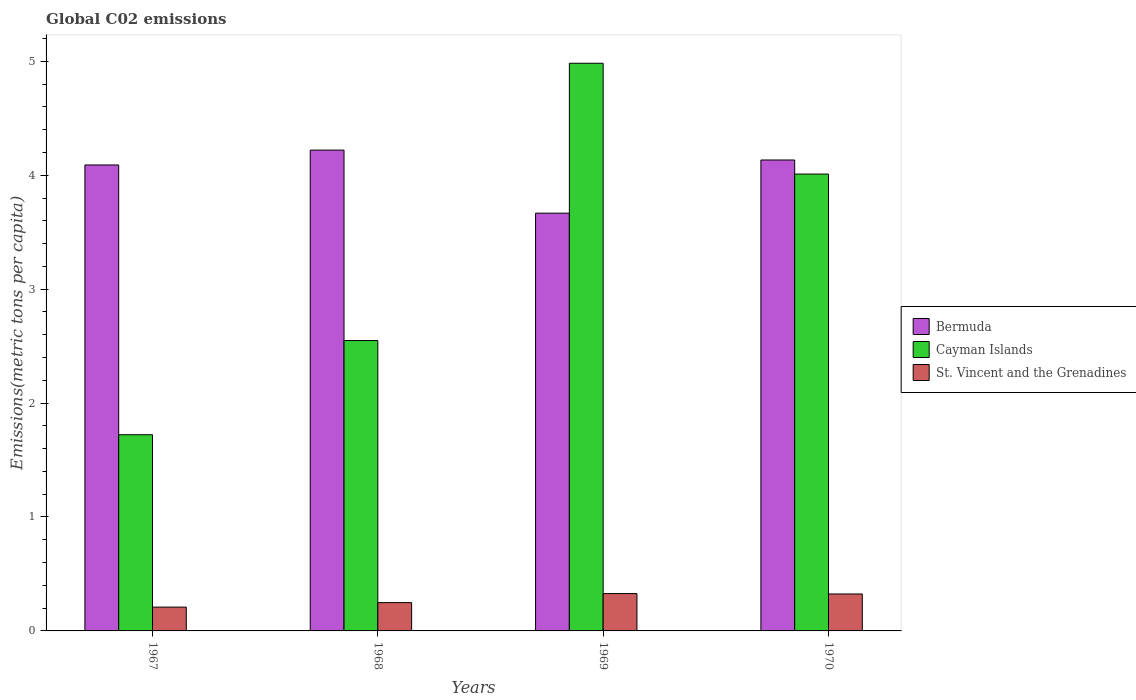How many different coloured bars are there?
Keep it short and to the point. 3. How many groups of bars are there?
Ensure brevity in your answer.  4. Are the number of bars per tick equal to the number of legend labels?
Your answer should be very brief. Yes. How many bars are there on the 3rd tick from the right?
Your answer should be compact. 3. What is the amount of CO2 emitted in in Bermuda in 1969?
Your answer should be compact. 3.67. Across all years, what is the maximum amount of CO2 emitted in in St. Vincent and the Grenadines?
Provide a succinct answer. 0.33. Across all years, what is the minimum amount of CO2 emitted in in Bermuda?
Your response must be concise. 3.67. In which year was the amount of CO2 emitted in in Bermuda maximum?
Keep it short and to the point. 1968. In which year was the amount of CO2 emitted in in Bermuda minimum?
Offer a very short reply. 1969. What is the total amount of CO2 emitted in in Cayman Islands in the graph?
Ensure brevity in your answer.  13.26. What is the difference between the amount of CO2 emitted in in Cayman Islands in 1967 and that in 1968?
Provide a short and direct response. -0.83. What is the difference between the amount of CO2 emitted in in Cayman Islands in 1969 and the amount of CO2 emitted in in Bermuda in 1970?
Provide a short and direct response. 0.85. What is the average amount of CO2 emitted in in Bermuda per year?
Provide a short and direct response. 4.03. In the year 1969, what is the difference between the amount of CO2 emitted in in Bermuda and amount of CO2 emitted in in Cayman Islands?
Give a very brief answer. -1.32. What is the ratio of the amount of CO2 emitted in in Cayman Islands in 1967 to that in 1970?
Ensure brevity in your answer.  0.43. Is the difference between the amount of CO2 emitted in in Bermuda in 1967 and 1969 greater than the difference between the amount of CO2 emitted in in Cayman Islands in 1967 and 1969?
Your response must be concise. Yes. What is the difference between the highest and the second highest amount of CO2 emitted in in Bermuda?
Provide a succinct answer. 0.09. What is the difference between the highest and the lowest amount of CO2 emitted in in Cayman Islands?
Make the answer very short. 3.26. Is the sum of the amount of CO2 emitted in in Cayman Islands in 1968 and 1969 greater than the maximum amount of CO2 emitted in in St. Vincent and the Grenadines across all years?
Your answer should be compact. Yes. What does the 1st bar from the left in 1969 represents?
Offer a very short reply. Bermuda. What does the 3rd bar from the right in 1968 represents?
Ensure brevity in your answer.  Bermuda. How many years are there in the graph?
Ensure brevity in your answer.  4. What is the difference between two consecutive major ticks on the Y-axis?
Keep it short and to the point. 1. Does the graph contain grids?
Provide a short and direct response. No. How many legend labels are there?
Offer a very short reply. 3. What is the title of the graph?
Provide a short and direct response. Global C02 emissions. What is the label or title of the X-axis?
Keep it short and to the point. Years. What is the label or title of the Y-axis?
Provide a short and direct response. Emissions(metric tons per capita). What is the Emissions(metric tons per capita) of Bermuda in 1967?
Give a very brief answer. 4.09. What is the Emissions(metric tons per capita) in Cayman Islands in 1967?
Ensure brevity in your answer.  1.72. What is the Emissions(metric tons per capita) in St. Vincent and the Grenadines in 1967?
Offer a terse response. 0.21. What is the Emissions(metric tons per capita) in Bermuda in 1968?
Give a very brief answer. 4.22. What is the Emissions(metric tons per capita) of Cayman Islands in 1968?
Ensure brevity in your answer.  2.55. What is the Emissions(metric tons per capita) of St. Vincent and the Grenadines in 1968?
Your response must be concise. 0.25. What is the Emissions(metric tons per capita) in Bermuda in 1969?
Give a very brief answer. 3.67. What is the Emissions(metric tons per capita) of Cayman Islands in 1969?
Provide a succinct answer. 4.98. What is the Emissions(metric tons per capita) of St. Vincent and the Grenadines in 1969?
Your answer should be compact. 0.33. What is the Emissions(metric tons per capita) in Bermuda in 1970?
Your answer should be very brief. 4.13. What is the Emissions(metric tons per capita) of Cayman Islands in 1970?
Your answer should be compact. 4.01. What is the Emissions(metric tons per capita) of St. Vincent and the Grenadines in 1970?
Your answer should be very brief. 0.32. Across all years, what is the maximum Emissions(metric tons per capita) of Bermuda?
Your answer should be very brief. 4.22. Across all years, what is the maximum Emissions(metric tons per capita) of Cayman Islands?
Provide a short and direct response. 4.98. Across all years, what is the maximum Emissions(metric tons per capita) in St. Vincent and the Grenadines?
Ensure brevity in your answer.  0.33. Across all years, what is the minimum Emissions(metric tons per capita) in Bermuda?
Provide a short and direct response. 3.67. Across all years, what is the minimum Emissions(metric tons per capita) in Cayman Islands?
Offer a very short reply. 1.72. Across all years, what is the minimum Emissions(metric tons per capita) of St. Vincent and the Grenadines?
Offer a terse response. 0.21. What is the total Emissions(metric tons per capita) of Bermuda in the graph?
Keep it short and to the point. 16.11. What is the total Emissions(metric tons per capita) of Cayman Islands in the graph?
Your answer should be very brief. 13.26. What is the total Emissions(metric tons per capita) in St. Vincent and the Grenadines in the graph?
Your response must be concise. 1.11. What is the difference between the Emissions(metric tons per capita) in Bermuda in 1967 and that in 1968?
Provide a succinct answer. -0.13. What is the difference between the Emissions(metric tons per capita) in Cayman Islands in 1967 and that in 1968?
Give a very brief answer. -0.83. What is the difference between the Emissions(metric tons per capita) of St. Vincent and the Grenadines in 1967 and that in 1968?
Your response must be concise. -0.04. What is the difference between the Emissions(metric tons per capita) of Bermuda in 1967 and that in 1969?
Offer a very short reply. 0.42. What is the difference between the Emissions(metric tons per capita) in Cayman Islands in 1967 and that in 1969?
Offer a terse response. -3.26. What is the difference between the Emissions(metric tons per capita) in St. Vincent and the Grenadines in 1967 and that in 1969?
Offer a very short reply. -0.12. What is the difference between the Emissions(metric tons per capita) in Bermuda in 1967 and that in 1970?
Make the answer very short. -0.04. What is the difference between the Emissions(metric tons per capita) of Cayman Islands in 1967 and that in 1970?
Ensure brevity in your answer.  -2.29. What is the difference between the Emissions(metric tons per capita) of St. Vincent and the Grenadines in 1967 and that in 1970?
Make the answer very short. -0.12. What is the difference between the Emissions(metric tons per capita) of Bermuda in 1968 and that in 1969?
Offer a terse response. 0.55. What is the difference between the Emissions(metric tons per capita) of Cayman Islands in 1968 and that in 1969?
Make the answer very short. -2.43. What is the difference between the Emissions(metric tons per capita) of St. Vincent and the Grenadines in 1968 and that in 1969?
Your answer should be very brief. -0.08. What is the difference between the Emissions(metric tons per capita) in Bermuda in 1968 and that in 1970?
Offer a very short reply. 0.09. What is the difference between the Emissions(metric tons per capita) of Cayman Islands in 1968 and that in 1970?
Make the answer very short. -1.46. What is the difference between the Emissions(metric tons per capita) in St. Vincent and the Grenadines in 1968 and that in 1970?
Provide a short and direct response. -0.08. What is the difference between the Emissions(metric tons per capita) in Bermuda in 1969 and that in 1970?
Provide a succinct answer. -0.47. What is the difference between the Emissions(metric tons per capita) in Cayman Islands in 1969 and that in 1970?
Your answer should be compact. 0.97. What is the difference between the Emissions(metric tons per capita) of St. Vincent and the Grenadines in 1969 and that in 1970?
Ensure brevity in your answer.  0. What is the difference between the Emissions(metric tons per capita) in Bermuda in 1967 and the Emissions(metric tons per capita) in Cayman Islands in 1968?
Offer a very short reply. 1.54. What is the difference between the Emissions(metric tons per capita) of Bermuda in 1967 and the Emissions(metric tons per capita) of St. Vincent and the Grenadines in 1968?
Give a very brief answer. 3.84. What is the difference between the Emissions(metric tons per capita) of Cayman Islands in 1967 and the Emissions(metric tons per capita) of St. Vincent and the Grenadines in 1968?
Your response must be concise. 1.47. What is the difference between the Emissions(metric tons per capita) of Bermuda in 1967 and the Emissions(metric tons per capita) of Cayman Islands in 1969?
Provide a short and direct response. -0.89. What is the difference between the Emissions(metric tons per capita) in Bermuda in 1967 and the Emissions(metric tons per capita) in St. Vincent and the Grenadines in 1969?
Provide a short and direct response. 3.76. What is the difference between the Emissions(metric tons per capita) in Cayman Islands in 1967 and the Emissions(metric tons per capita) in St. Vincent and the Grenadines in 1969?
Offer a terse response. 1.39. What is the difference between the Emissions(metric tons per capita) in Bermuda in 1967 and the Emissions(metric tons per capita) in Cayman Islands in 1970?
Ensure brevity in your answer.  0.08. What is the difference between the Emissions(metric tons per capita) in Bermuda in 1967 and the Emissions(metric tons per capita) in St. Vincent and the Grenadines in 1970?
Give a very brief answer. 3.77. What is the difference between the Emissions(metric tons per capita) in Cayman Islands in 1967 and the Emissions(metric tons per capita) in St. Vincent and the Grenadines in 1970?
Give a very brief answer. 1.4. What is the difference between the Emissions(metric tons per capita) in Bermuda in 1968 and the Emissions(metric tons per capita) in Cayman Islands in 1969?
Offer a very short reply. -0.76. What is the difference between the Emissions(metric tons per capita) of Bermuda in 1968 and the Emissions(metric tons per capita) of St. Vincent and the Grenadines in 1969?
Offer a terse response. 3.89. What is the difference between the Emissions(metric tons per capita) of Cayman Islands in 1968 and the Emissions(metric tons per capita) of St. Vincent and the Grenadines in 1969?
Give a very brief answer. 2.22. What is the difference between the Emissions(metric tons per capita) of Bermuda in 1968 and the Emissions(metric tons per capita) of Cayman Islands in 1970?
Make the answer very short. 0.21. What is the difference between the Emissions(metric tons per capita) of Bermuda in 1968 and the Emissions(metric tons per capita) of St. Vincent and the Grenadines in 1970?
Offer a terse response. 3.9. What is the difference between the Emissions(metric tons per capita) of Cayman Islands in 1968 and the Emissions(metric tons per capita) of St. Vincent and the Grenadines in 1970?
Make the answer very short. 2.22. What is the difference between the Emissions(metric tons per capita) of Bermuda in 1969 and the Emissions(metric tons per capita) of Cayman Islands in 1970?
Provide a short and direct response. -0.34. What is the difference between the Emissions(metric tons per capita) of Bermuda in 1969 and the Emissions(metric tons per capita) of St. Vincent and the Grenadines in 1970?
Give a very brief answer. 3.34. What is the difference between the Emissions(metric tons per capita) of Cayman Islands in 1969 and the Emissions(metric tons per capita) of St. Vincent and the Grenadines in 1970?
Ensure brevity in your answer.  4.66. What is the average Emissions(metric tons per capita) in Bermuda per year?
Provide a succinct answer. 4.03. What is the average Emissions(metric tons per capita) of Cayman Islands per year?
Keep it short and to the point. 3.32. What is the average Emissions(metric tons per capita) in St. Vincent and the Grenadines per year?
Your response must be concise. 0.28. In the year 1967, what is the difference between the Emissions(metric tons per capita) of Bermuda and Emissions(metric tons per capita) of Cayman Islands?
Make the answer very short. 2.37. In the year 1967, what is the difference between the Emissions(metric tons per capita) in Bermuda and Emissions(metric tons per capita) in St. Vincent and the Grenadines?
Make the answer very short. 3.88. In the year 1967, what is the difference between the Emissions(metric tons per capita) of Cayman Islands and Emissions(metric tons per capita) of St. Vincent and the Grenadines?
Your answer should be compact. 1.51. In the year 1968, what is the difference between the Emissions(metric tons per capita) in Bermuda and Emissions(metric tons per capita) in Cayman Islands?
Make the answer very short. 1.67. In the year 1968, what is the difference between the Emissions(metric tons per capita) of Bermuda and Emissions(metric tons per capita) of St. Vincent and the Grenadines?
Offer a terse response. 3.97. In the year 1968, what is the difference between the Emissions(metric tons per capita) of Cayman Islands and Emissions(metric tons per capita) of St. Vincent and the Grenadines?
Your response must be concise. 2.3. In the year 1969, what is the difference between the Emissions(metric tons per capita) of Bermuda and Emissions(metric tons per capita) of Cayman Islands?
Offer a very short reply. -1.32. In the year 1969, what is the difference between the Emissions(metric tons per capita) of Bermuda and Emissions(metric tons per capita) of St. Vincent and the Grenadines?
Your answer should be very brief. 3.34. In the year 1969, what is the difference between the Emissions(metric tons per capita) in Cayman Islands and Emissions(metric tons per capita) in St. Vincent and the Grenadines?
Your answer should be compact. 4.66. In the year 1970, what is the difference between the Emissions(metric tons per capita) in Bermuda and Emissions(metric tons per capita) in Cayman Islands?
Keep it short and to the point. 0.12. In the year 1970, what is the difference between the Emissions(metric tons per capita) of Bermuda and Emissions(metric tons per capita) of St. Vincent and the Grenadines?
Ensure brevity in your answer.  3.81. In the year 1970, what is the difference between the Emissions(metric tons per capita) of Cayman Islands and Emissions(metric tons per capita) of St. Vincent and the Grenadines?
Provide a succinct answer. 3.69. What is the ratio of the Emissions(metric tons per capita) in Bermuda in 1967 to that in 1968?
Your response must be concise. 0.97. What is the ratio of the Emissions(metric tons per capita) of Cayman Islands in 1967 to that in 1968?
Give a very brief answer. 0.68. What is the ratio of the Emissions(metric tons per capita) in St. Vincent and the Grenadines in 1967 to that in 1968?
Make the answer very short. 0.84. What is the ratio of the Emissions(metric tons per capita) of Bermuda in 1967 to that in 1969?
Your answer should be very brief. 1.12. What is the ratio of the Emissions(metric tons per capita) of Cayman Islands in 1967 to that in 1969?
Your response must be concise. 0.35. What is the ratio of the Emissions(metric tons per capita) in St. Vincent and the Grenadines in 1967 to that in 1969?
Offer a terse response. 0.64. What is the ratio of the Emissions(metric tons per capita) of Cayman Islands in 1967 to that in 1970?
Ensure brevity in your answer.  0.43. What is the ratio of the Emissions(metric tons per capita) in St. Vincent and the Grenadines in 1967 to that in 1970?
Give a very brief answer. 0.64. What is the ratio of the Emissions(metric tons per capita) in Bermuda in 1968 to that in 1969?
Keep it short and to the point. 1.15. What is the ratio of the Emissions(metric tons per capita) in Cayman Islands in 1968 to that in 1969?
Your answer should be very brief. 0.51. What is the ratio of the Emissions(metric tons per capita) in St. Vincent and the Grenadines in 1968 to that in 1969?
Offer a very short reply. 0.76. What is the ratio of the Emissions(metric tons per capita) of Cayman Islands in 1968 to that in 1970?
Make the answer very short. 0.64. What is the ratio of the Emissions(metric tons per capita) in St. Vincent and the Grenadines in 1968 to that in 1970?
Keep it short and to the point. 0.77. What is the ratio of the Emissions(metric tons per capita) of Bermuda in 1969 to that in 1970?
Make the answer very short. 0.89. What is the ratio of the Emissions(metric tons per capita) of Cayman Islands in 1969 to that in 1970?
Provide a short and direct response. 1.24. What is the ratio of the Emissions(metric tons per capita) in St. Vincent and the Grenadines in 1969 to that in 1970?
Make the answer very short. 1.01. What is the difference between the highest and the second highest Emissions(metric tons per capita) in Bermuda?
Ensure brevity in your answer.  0.09. What is the difference between the highest and the second highest Emissions(metric tons per capita) in Cayman Islands?
Offer a very short reply. 0.97. What is the difference between the highest and the second highest Emissions(metric tons per capita) in St. Vincent and the Grenadines?
Provide a short and direct response. 0. What is the difference between the highest and the lowest Emissions(metric tons per capita) in Bermuda?
Ensure brevity in your answer.  0.55. What is the difference between the highest and the lowest Emissions(metric tons per capita) in Cayman Islands?
Provide a short and direct response. 3.26. What is the difference between the highest and the lowest Emissions(metric tons per capita) in St. Vincent and the Grenadines?
Your response must be concise. 0.12. 